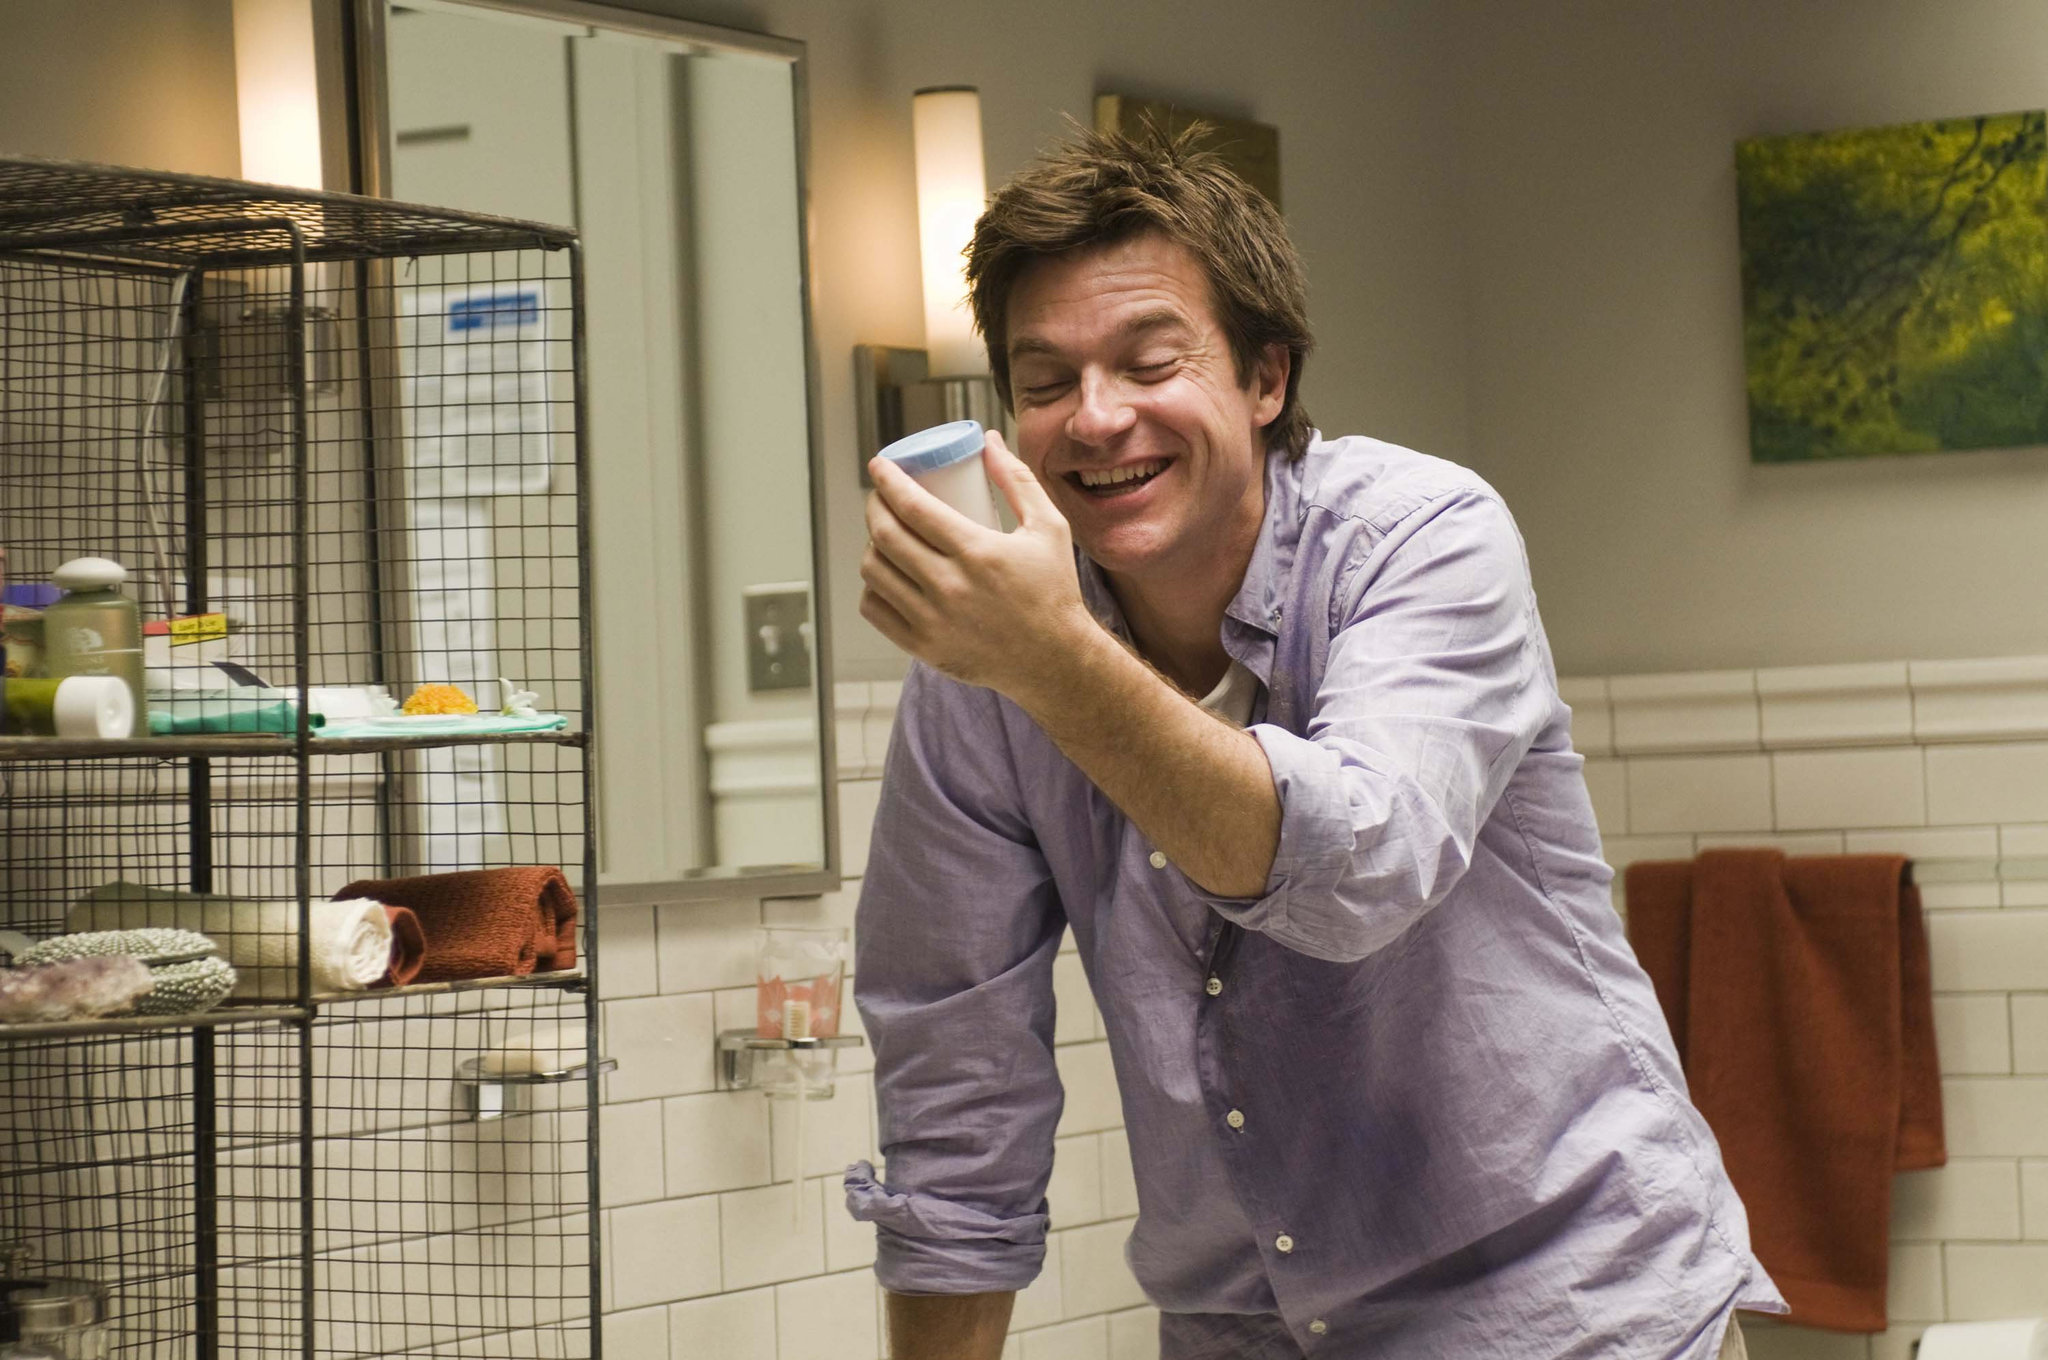What are the key elements in this picture? In this image, we see a man standing in a bathroom, seemingly enjoying a moment of humor or joy. He is in front of a white sink, laughing and holding a blue cup to his face. The man is dressed in a casual purple button-down shirt. To his left, a towel is casually draped on a shelf alongside various toiletries. An interesting addition to the scene is a birdcage housing a yellow bird, which is quite unexpected for a bathroom setting. The bathroom has a white tiled wall, and the background is adorned with a painting of a tree. The lighting is warm, contributing to the overall cheerful ambiance of the scene. 